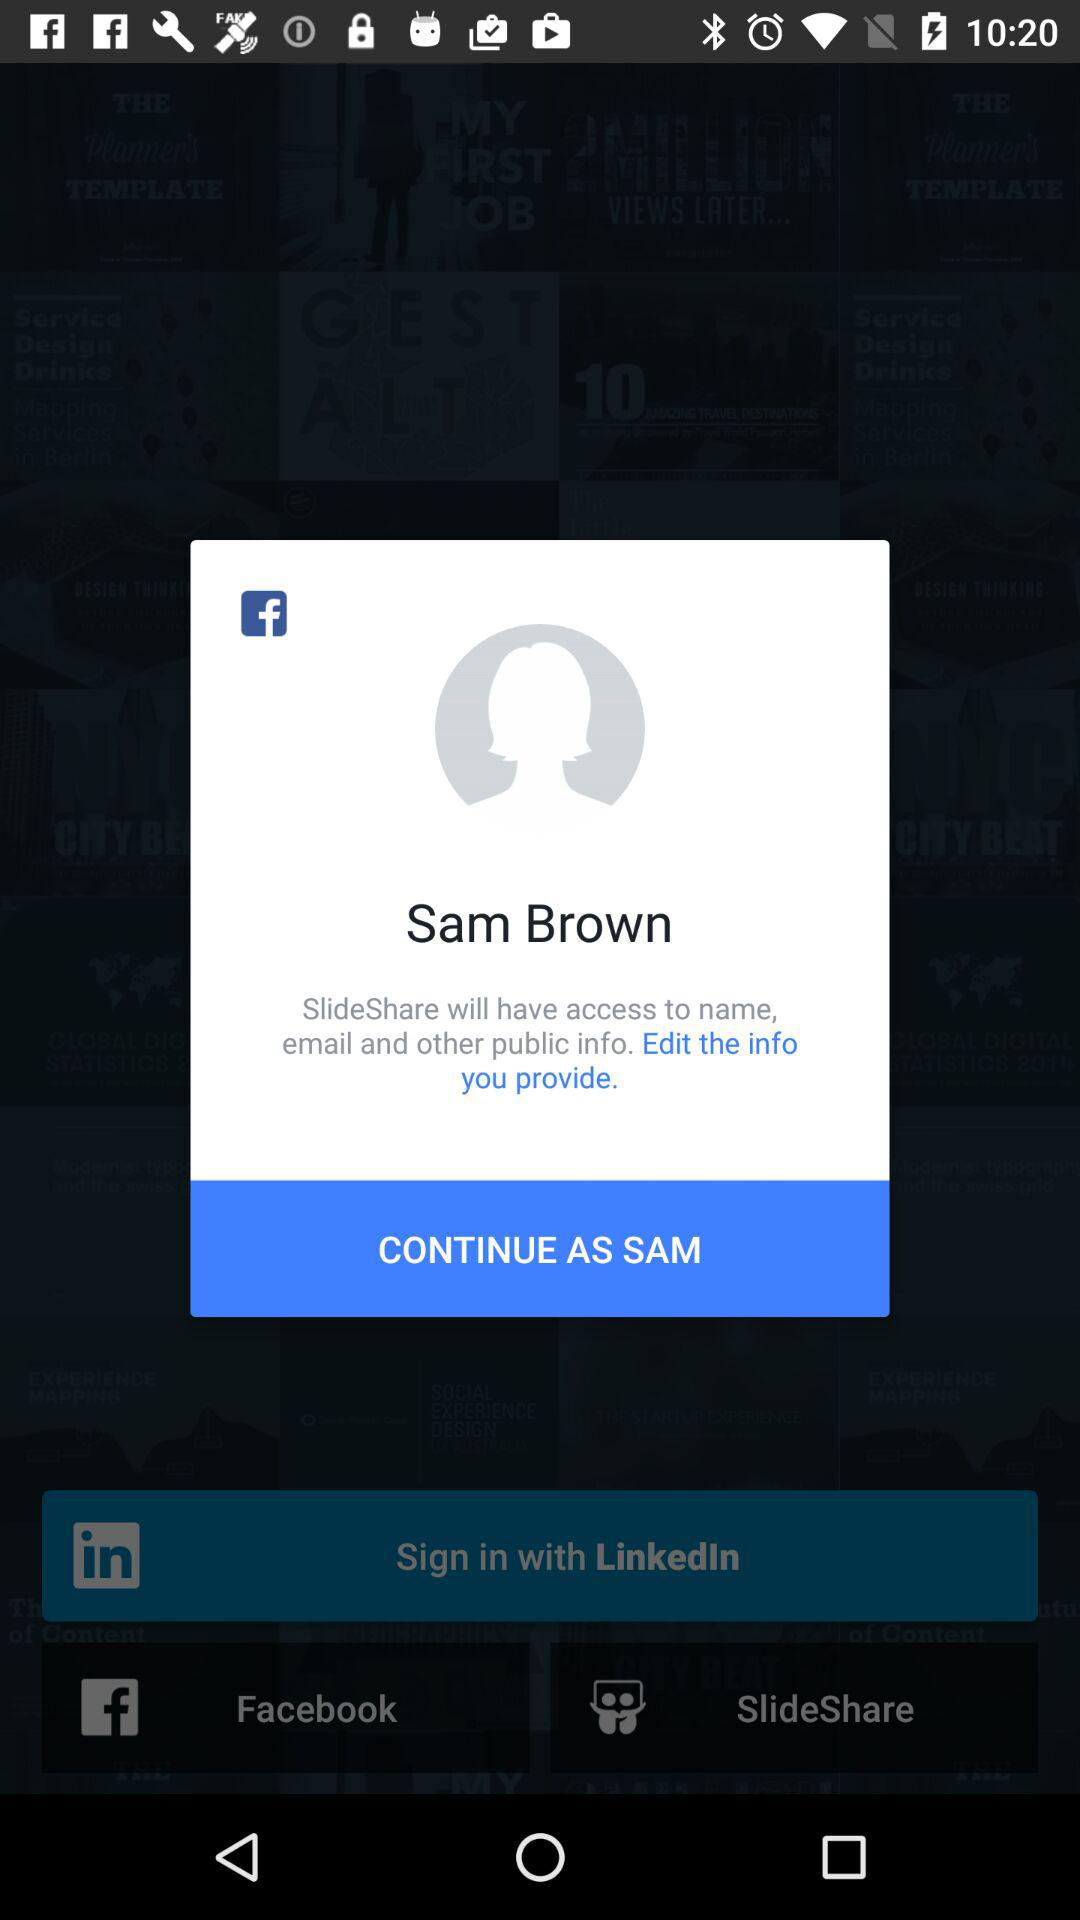How many public information items will SlideShare have access to?
Answer the question using a single word or phrase. 3 